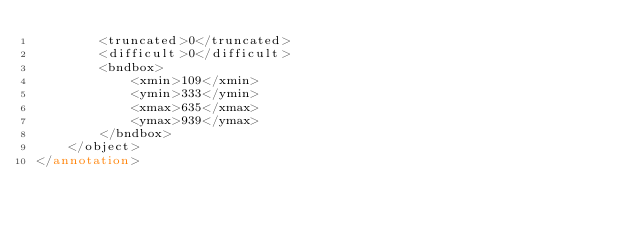<code> <loc_0><loc_0><loc_500><loc_500><_XML_>		<truncated>0</truncated>
		<difficult>0</difficult>
		<bndbox>
			<xmin>109</xmin>
			<ymin>333</ymin>
			<xmax>635</xmax>
			<ymax>939</ymax>
		</bndbox>
	</object>
</annotation>
</code> 